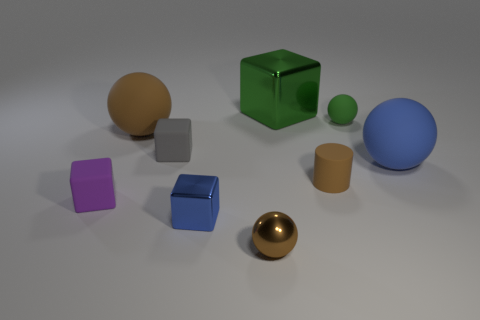Subtract 1 cubes. How many cubes are left? 3 Add 1 large blue matte balls. How many objects exist? 10 Subtract all cylinders. How many objects are left? 8 Subtract all big purple balls. Subtract all small metallic objects. How many objects are left? 7 Add 3 big metallic things. How many big metallic things are left? 4 Add 6 shiny cubes. How many shiny cubes exist? 8 Subtract 1 green blocks. How many objects are left? 8 